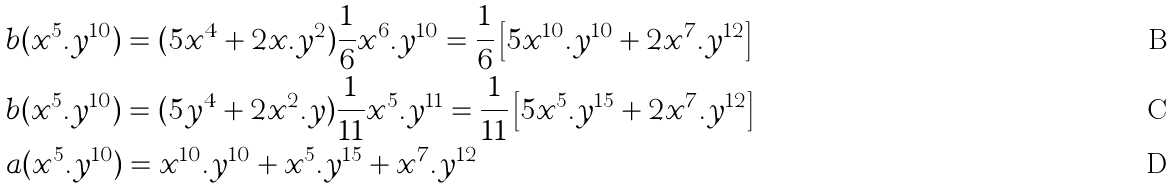<formula> <loc_0><loc_0><loc_500><loc_500>& b ( x ^ { 5 } . y ^ { 1 0 } ) = ( 5 x ^ { 4 } + 2 x . y ^ { 2 } ) \frac { 1 } { 6 } x ^ { 6 } . y ^ { 1 0 } = \frac { 1 } { 6 } \left [ 5 x ^ { 1 0 } . y ^ { 1 0 } + 2 x ^ { 7 } . y ^ { 1 2 } \right ] \\ & b ( x ^ { 5 } . y ^ { 1 0 } ) = ( 5 y ^ { 4 } + 2 x ^ { 2 } . y ) \frac { 1 } { 1 1 } x ^ { 5 } . y ^ { 1 1 } = \frac { 1 } { 1 1 } \left [ 5 x ^ { 5 } . y ^ { 1 5 } + 2 x ^ { 7 } . y ^ { 1 2 } \right ] \\ & a ( x ^ { 5 } . y ^ { 1 0 } ) = x ^ { 1 0 } . y ^ { 1 0 } + x ^ { 5 } . y ^ { 1 5 } + x ^ { 7 } . y ^ { 1 2 }</formula> 